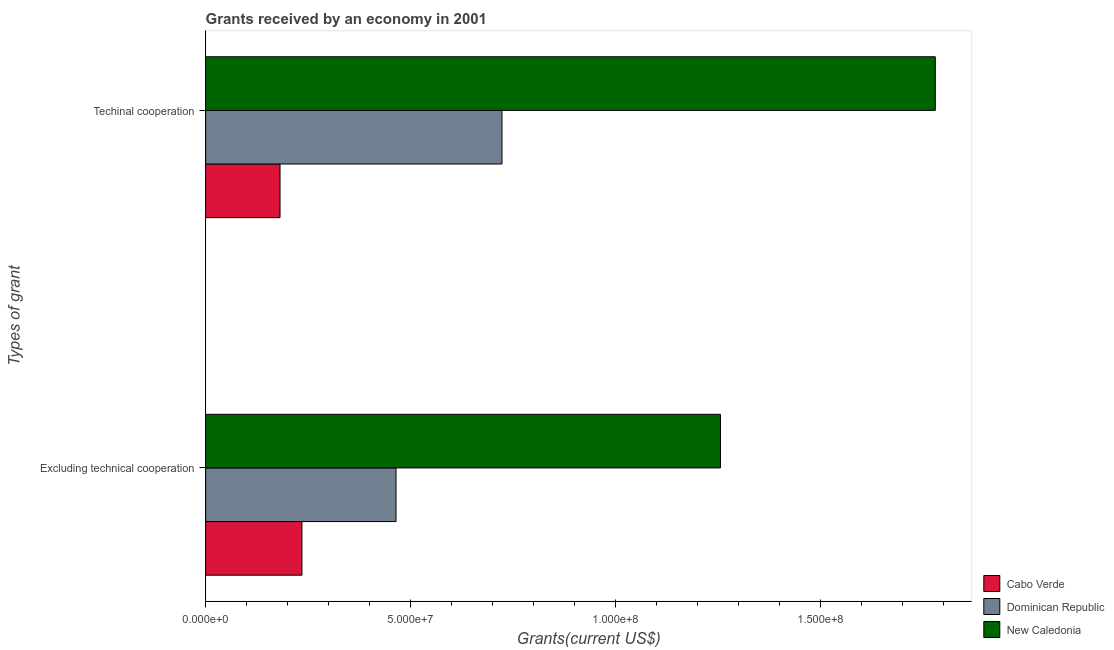How many different coloured bars are there?
Your response must be concise. 3. How many groups of bars are there?
Keep it short and to the point. 2. Are the number of bars on each tick of the Y-axis equal?
Your response must be concise. Yes. How many bars are there on the 2nd tick from the top?
Offer a terse response. 3. How many bars are there on the 2nd tick from the bottom?
Give a very brief answer. 3. What is the label of the 2nd group of bars from the top?
Keep it short and to the point. Excluding technical cooperation. What is the amount of grants received(including technical cooperation) in New Caledonia?
Make the answer very short. 1.78e+08. Across all countries, what is the maximum amount of grants received(including technical cooperation)?
Provide a short and direct response. 1.78e+08. Across all countries, what is the minimum amount of grants received(including technical cooperation)?
Give a very brief answer. 1.81e+07. In which country was the amount of grants received(excluding technical cooperation) maximum?
Give a very brief answer. New Caledonia. In which country was the amount of grants received(excluding technical cooperation) minimum?
Keep it short and to the point. Cabo Verde. What is the total amount of grants received(including technical cooperation) in the graph?
Your answer should be very brief. 2.68e+08. What is the difference between the amount of grants received(excluding technical cooperation) in Cabo Verde and that in Dominican Republic?
Offer a very short reply. -2.29e+07. What is the difference between the amount of grants received(excluding technical cooperation) in Dominican Republic and the amount of grants received(including technical cooperation) in Cabo Verde?
Provide a short and direct response. 2.83e+07. What is the average amount of grants received(excluding technical cooperation) per country?
Offer a very short reply. 6.51e+07. What is the difference between the amount of grants received(including technical cooperation) and amount of grants received(excluding technical cooperation) in Dominican Republic?
Provide a succinct answer. 2.58e+07. In how many countries, is the amount of grants received(including technical cooperation) greater than 90000000 US$?
Make the answer very short. 1. What is the ratio of the amount of grants received(including technical cooperation) in New Caledonia to that in Cabo Verde?
Provide a short and direct response. 9.81. Is the amount of grants received(excluding technical cooperation) in Dominican Republic less than that in Cabo Verde?
Keep it short and to the point. No. In how many countries, is the amount of grants received(excluding technical cooperation) greater than the average amount of grants received(excluding technical cooperation) taken over all countries?
Give a very brief answer. 1. What does the 3rd bar from the top in Excluding technical cooperation represents?
Give a very brief answer. Cabo Verde. What does the 1st bar from the bottom in Excluding technical cooperation represents?
Your answer should be compact. Cabo Verde. Are all the bars in the graph horizontal?
Give a very brief answer. Yes. How many countries are there in the graph?
Offer a terse response. 3. What is the difference between two consecutive major ticks on the X-axis?
Give a very brief answer. 5.00e+07. Are the values on the major ticks of X-axis written in scientific E-notation?
Your answer should be very brief. Yes. How many legend labels are there?
Offer a terse response. 3. What is the title of the graph?
Provide a succinct answer. Grants received by an economy in 2001. What is the label or title of the X-axis?
Ensure brevity in your answer.  Grants(current US$). What is the label or title of the Y-axis?
Make the answer very short. Types of grant. What is the Grants(current US$) of Cabo Verde in Excluding technical cooperation?
Make the answer very short. 2.35e+07. What is the Grants(current US$) of Dominican Republic in Excluding technical cooperation?
Ensure brevity in your answer.  4.64e+07. What is the Grants(current US$) of New Caledonia in Excluding technical cooperation?
Ensure brevity in your answer.  1.26e+08. What is the Grants(current US$) in Cabo Verde in Techinal cooperation?
Offer a terse response. 1.81e+07. What is the Grants(current US$) of Dominican Republic in Techinal cooperation?
Offer a very short reply. 7.22e+07. What is the Grants(current US$) in New Caledonia in Techinal cooperation?
Offer a very short reply. 1.78e+08. Across all Types of grant, what is the maximum Grants(current US$) in Cabo Verde?
Give a very brief answer. 2.35e+07. Across all Types of grant, what is the maximum Grants(current US$) of Dominican Republic?
Make the answer very short. 7.22e+07. Across all Types of grant, what is the maximum Grants(current US$) in New Caledonia?
Your answer should be very brief. 1.78e+08. Across all Types of grant, what is the minimum Grants(current US$) of Cabo Verde?
Give a very brief answer. 1.81e+07. Across all Types of grant, what is the minimum Grants(current US$) of Dominican Republic?
Offer a very short reply. 4.64e+07. Across all Types of grant, what is the minimum Grants(current US$) in New Caledonia?
Give a very brief answer. 1.26e+08. What is the total Grants(current US$) in Cabo Verde in the graph?
Provide a short and direct response. 4.16e+07. What is the total Grants(current US$) of Dominican Republic in the graph?
Provide a succinct answer. 1.19e+08. What is the total Grants(current US$) in New Caledonia in the graph?
Give a very brief answer. 3.03e+08. What is the difference between the Grants(current US$) of Cabo Verde in Excluding technical cooperation and that in Techinal cooperation?
Offer a terse response. 5.34e+06. What is the difference between the Grants(current US$) in Dominican Republic in Excluding technical cooperation and that in Techinal cooperation?
Your answer should be compact. -2.58e+07. What is the difference between the Grants(current US$) in New Caledonia in Excluding technical cooperation and that in Techinal cooperation?
Your response must be concise. -5.24e+07. What is the difference between the Grants(current US$) in Cabo Verde in Excluding technical cooperation and the Grants(current US$) in Dominican Republic in Techinal cooperation?
Give a very brief answer. -4.88e+07. What is the difference between the Grants(current US$) in Cabo Verde in Excluding technical cooperation and the Grants(current US$) in New Caledonia in Techinal cooperation?
Provide a short and direct response. -1.54e+08. What is the difference between the Grants(current US$) of Dominican Republic in Excluding technical cooperation and the Grants(current US$) of New Caledonia in Techinal cooperation?
Your answer should be very brief. -1.31e+08. What is the average Grants(current US$) in Cabo Verde per Types of grant?
Your answer should be very brief. 2.08e+07. What is the average Grants(current US$) of Dominican Republic per Types of grant?
Make the answer very short. 5.93e+07. What is the average Grants(current US$) in New Caledonia per Types of grant?
Give a very brief answer. 1.52e+08. What is the difference between the Grants(current US$) in Cabo Verde and Grants(current US$) in Dominican Republic in Excluding technical cooperation?
Your answer should be very brief. -2.29e+07. What is the difference between the Grants(current US$) of Cabo Verde and Grants(current US$) of New Caledonia in Excluding technical cooperation?
Your response must be concise. -1.02e+08. What is the difference between the Grants(current US$) of Dominican Republic and Grants(current US$) of New Caledonia in Excluding technical cooperation?
Make the answer very short. -7.91e+07. What is the difference between the Grants(current US$) in Cabo Verde and Grants(current US$) in Dominican Republic in Techinal cooperation?
Provide a succinct answer. -5.41e+07. What is the difference between the Grants(current US$) of Cabo Verde and Grants(current US$) of New Caledonia in Techinal cooperation?
Ensure brevity in your answer.  -1.60e+08. What is the difference between the Grants(current US$) in Dominican Republic and Grants(current US$) in New Caledonia in Techinal cooperation?
Your response must be concise. -1.06e+08. What is the ratio of the Grants(current US$) in Cabo Verde in Excluding technical cooperation to that in Techinal cooperation?
Keep it short and to the point. 1.29. What is the ratio of the Grants(current US$) of Dominican Republic in Excluding technical cooperation to that in Techinal cooperation?
Your response must be concise. 0.64. What is the ratio of the Grants(current US$) in New Caledonia in Excluding technical cooperation to that in Techinal cooperation?
Give a very brief answer. 0.71. What is the difference between the highest and the second highest Grants(current US$) in Cabo Verde?
Your answer should be very brief. 5.34e+06. What is the difference between the highest and the second highest Grants(current US$) in Dominican Republic?
Provide a short and direct response. 2.58e+07. What is the difference between the highest and the second highest Grants(current US$) of New Caledonia?
Offer a very short reply. 5.24e+07. What is the difference between the highest and the lowest Grants(current US$) in Cabo Verde?
Your answer should be compact. 5.34e+06. What is the difference between the highest and the lowest Grants(current US$) of Dominican Republic?
Keep it short and to the point. 2.58e+07. What is the difference between the highest and the lowest Grants(current US$) of New Caledonia?
Offer a very short reply. 5.24e+07. 